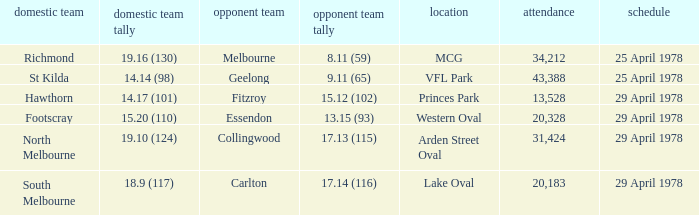What was the away team that played at Princes Park? Fitzroy. 